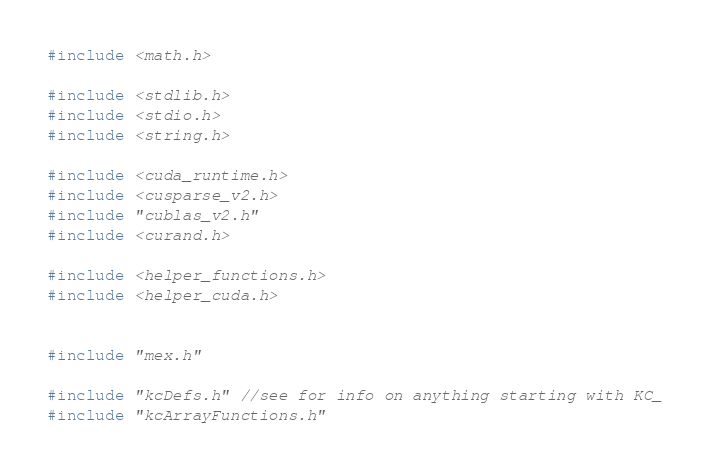Convert code to text. <code><loc_0><loc_0><loc_500><loc_500><_Cuda_>
#include <math.h>

#include <stdlib.h>
#include <stdio.h>
#include <string.h>

#include <cuda_runtime.h>
#include <cusparse_v2.h>
#include "cublas_v2.h"
#include <curand.h>

#include <helper_functions.h>
#include <helper_cuda.h>


#include "mex.h"

#include "kcDefs.h" //see for info on anything starting with KC_
#include "kcArrayFunctions.h"
</code> 